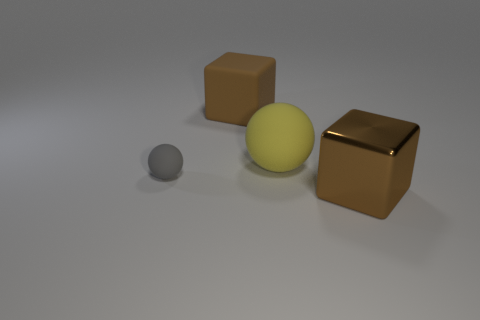Add 3 small rubber spheres. How many objects exist? 7 Subtract 0 purple cylinders. How many objects are left? 4 Subtract all small things. Subtract all yellow things. How many objects are left? 2 Add 2 large brown matte things. How many large brown matte things are left? 3 Add 1 big shiny blocks. How many big shiny blocks exist? 2 